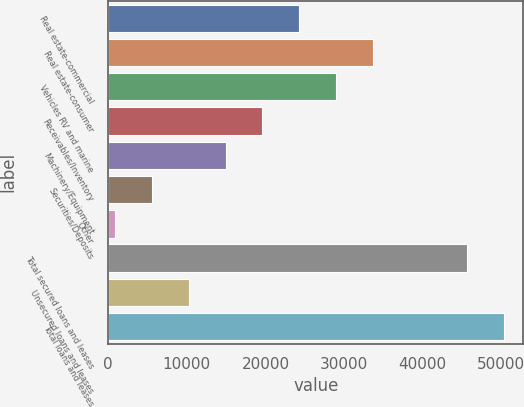<chart> <loc_0><loc_0><loc_500><loc_500><bar_chart><fcel>Real estate-commercial<fcel>Real estate-consumer<fcel>Vehicles RV and marine<fcel>Receivables/Inventory<fcel>Machinery/Equipment<fcel>Securities/Deposits<fcel>Other<fcel>Total secured loans and leases<fcel>Unsecured loans and leases<fcel>Total loans and leases<nl><fcel>24287.5<fcel>33634.9<fcel>28961.2<fcel>19613.8<fcel>14940.1<fcel>5592.7<fcel>919<fcel>45599<fcel>10266.4<fcel>50272.7<nl></chart> 